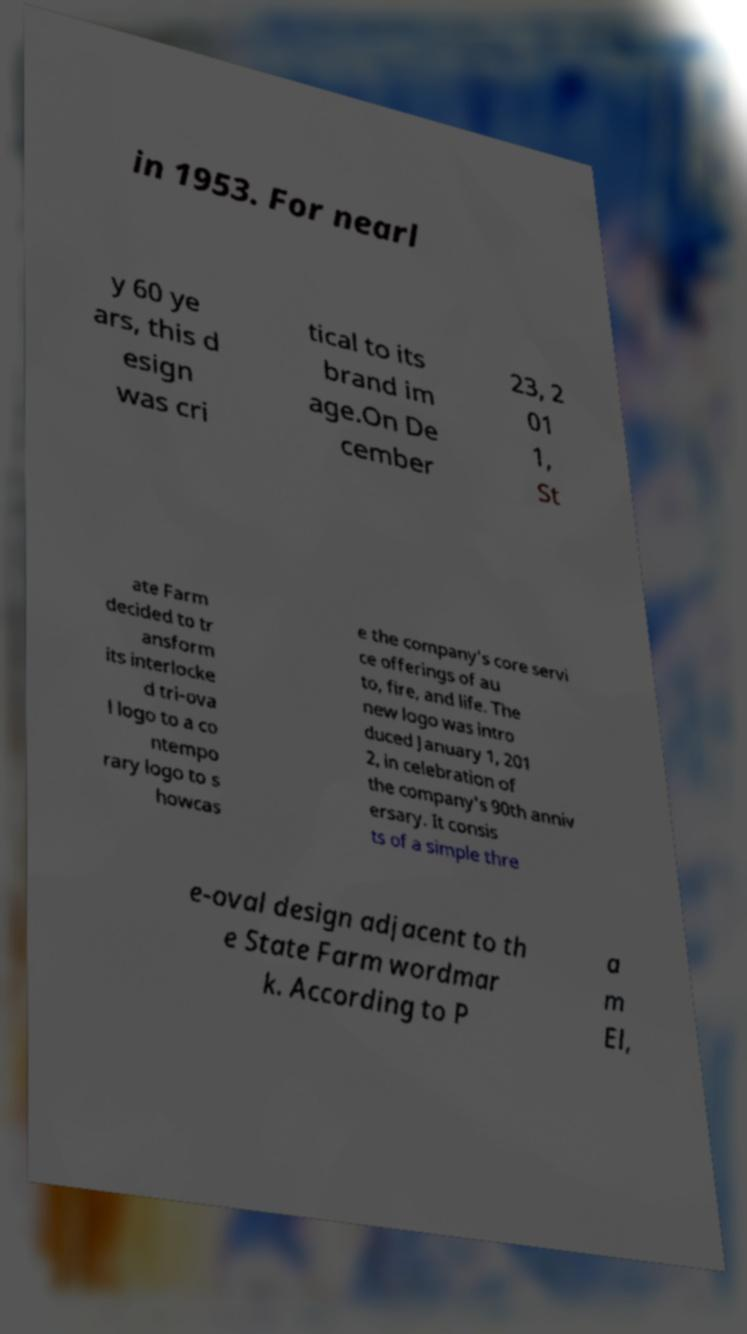For documentation purposes, I need the text within this image transcribed. Could you provide that? in 1953. For nearl y 60 ye ars, this d esign was cri tical to its brand im age.On De cember 23, 2 01 1, St ate Farm decided to tr ansform its interlocke d tri-ova l logo to a co ntempo rary logo to s howcas e the company's core servi ce offerings of au to, fire, and life. The new logo was intro duced January 1, 201 2, in celebration of the company's 90th anniv ersary. It consis ts of a simple thre e-oval design adjacent to th e State Farm wordmar k. According to P a m El, 